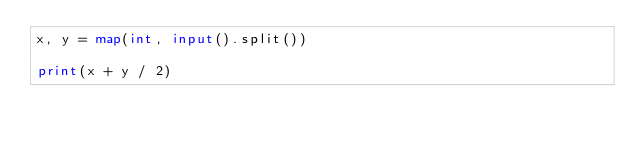<code> <loc_0><loc_0><loc_500><loc_500><_Python_>x, y = map(int, input().split())
               
print(x + y / 2)
</code> 